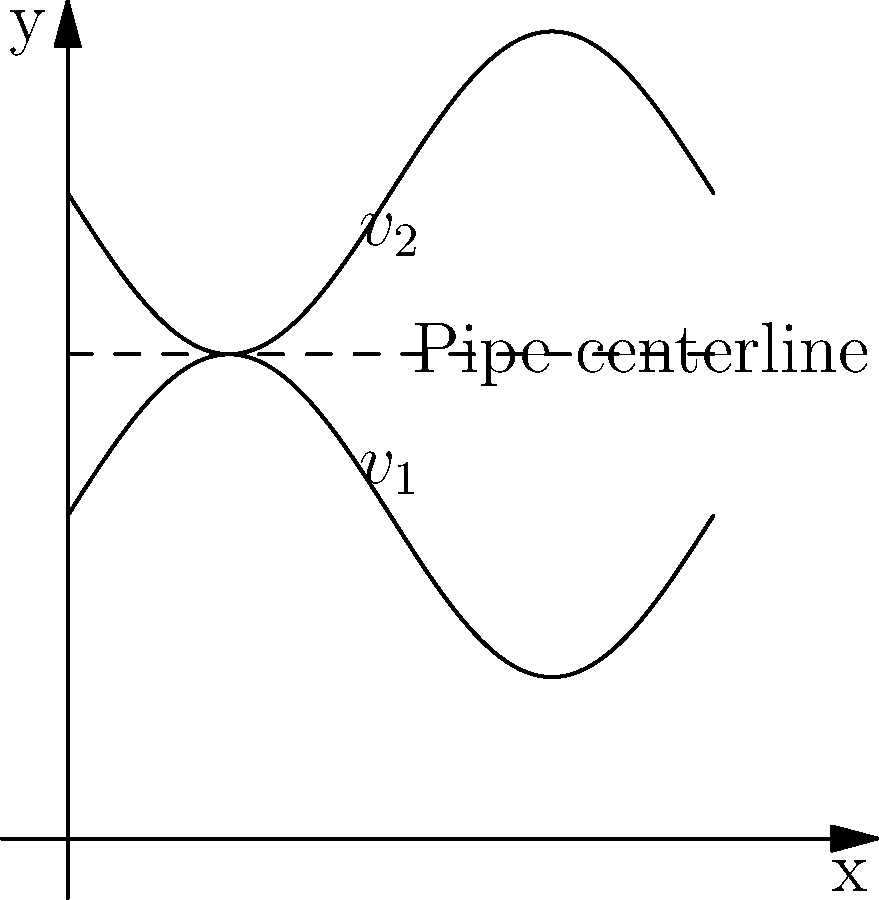In a pipe with a varying diameter as shown in the figure, where $v_1$ and $v_2$ represent the fluid velocities at the top and bottom of the pipe respectively, how does the velocity profile change along the pipe's length? Consider the implications of the continuity equation in your response. To understand the velocity profile change, let's follow these steps:

1. Continuity Equation: For incompressible flow, the continuity equation states that the mass flow rate remains constant along the pipe. Mathematically, this is expressed as:

   $$A_1v_1 = A_2v_2 = \text{constant}$$

   where $A$ is the cross-sectional area and $v$ is the average velocity.

2. Varying Diameter: As the pipe diameter changes, the cross-sectional area changes. When the area decreases, the velocity must increase to maintain constant flow rate, and vice versa.

3. Velocity Profile: In a pipe flow, the velocity is typically highest at the center and zero at the walls due to the no-slip condition. The profile is usually parabolic for laminar flow.

4. Profile Change: As the pipe narrows, the velocity profile becomes more stretched vertically, with a higher maximum velocity at the center. As the pipe widens, the profile becomes flatter with a lower maximum velocity.

5. Conservation of Energy: The total energy (kinetic + potential + pressure) remains constant along the pipe (neglecting losses). As velocity increases in narrow sections, pressure decreases, and vice versa.

6. Boundary Layer: The boundary layer thickness relative to the pipe radius changes with diameter, affecting the shape of the velocity profile.

Given the sinusoidal variation of the pipe diameter shown in the figure, the velocity profile will continuously adjust, being more stretched in narrow sections and flatter in wider sections, while maintaining constant volumetric flow rate throughout the pipe length.
Answer: The velocity profile stretches vertically in narrow sections and flattens in wider sections, maintaining constant volumetric flow rate. 